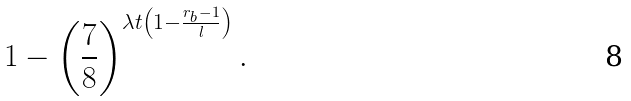<formula> <loc_0><loc_0><loc_500><loc_500>1 - \left ( \frac { 7 } { 8 } \right ) ^ { \lambda t \left ( 1 - \frac { r _ { b } - 1 } { l } \right ) } .</formula> 